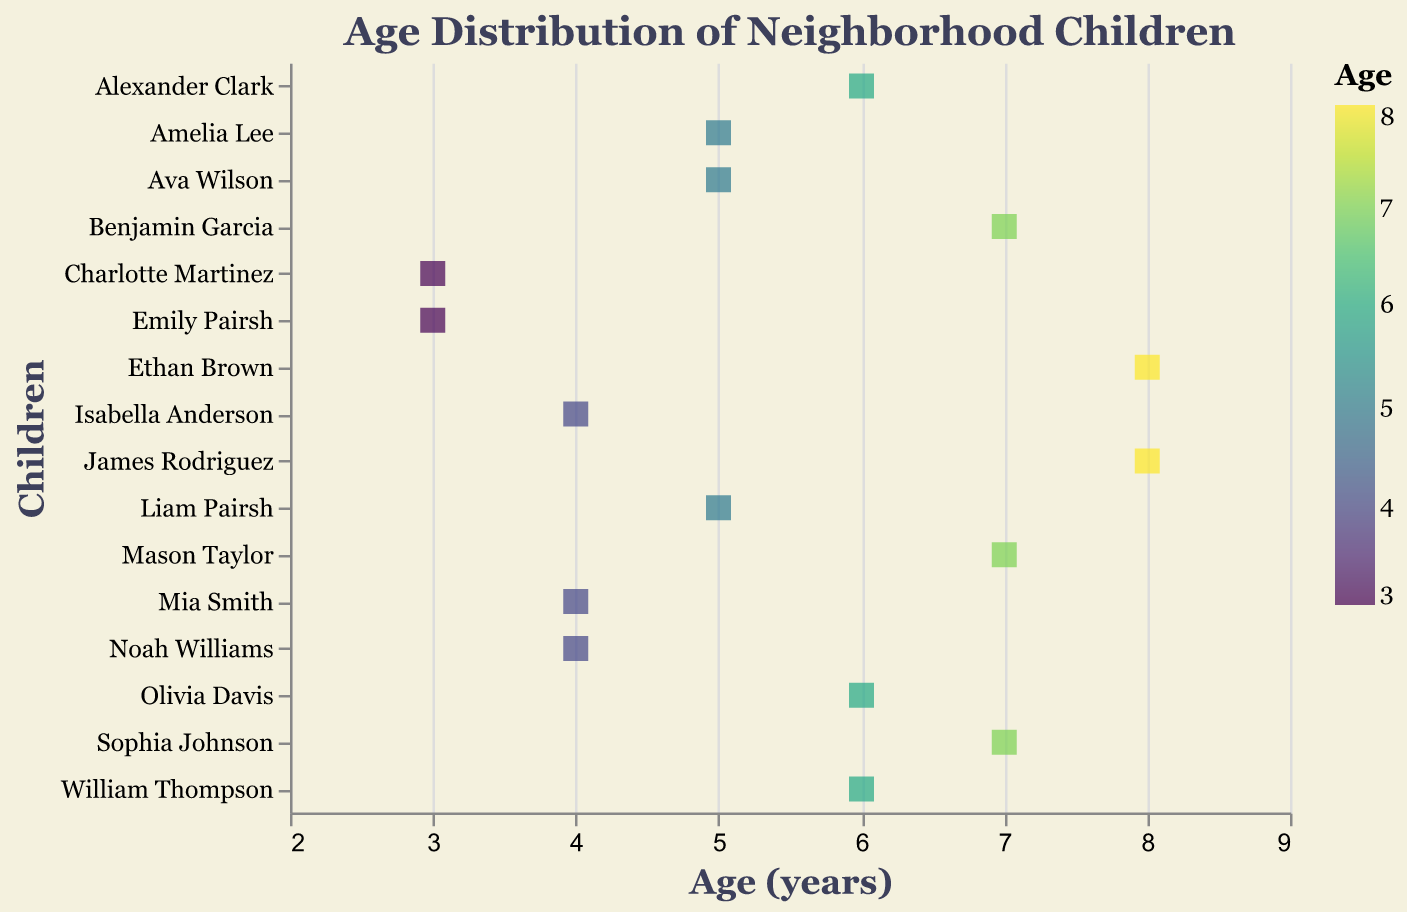What is the age range of the neighborhood children in the plot? The horizontal axis represents the children's ages. The lowest age value is 3 years, and the highest is 8 years.
Answer: 3 to 8 years How many children are aged 5 in the plot? By inspecting the plot, we observe that there are three data points (Liam Pairsh, Ava Wilson, and Amelia Lee) at the age of 5.
Answer: 3 children Which age has the highest frequency of children? We compare the number of children at each age: there are three children aged 5, three aged 7, and three aged 6. Therefore, ages 5, 6, and 7 all have the highest frequency.
Answer: 5, 6, and 7 Who is the youngest child, and what is their age? The plot shows two data points at the age of 3: Emily Pairsh and Charlotte Martinez. Both are the youngest, aged 3.
Answer: Emily Pairsh and Charlotte Martinez, age 3 Which child is aged 8 years old? By looking at the plot, we see Ethan Brown and James Rodriguez are represented at age 8.
Answer: Ethan Brown and James Rodriguez What is the median age of the children in the plot? Sorting the ages: 3, 3, 4, 4, 4, 5, 5, 5, 6, 6, 6, 7, 7, 7, 8, 8. With 16 children, the median is the average of the 8th and 9th values: (5+6)/2.
Answer: 5.5 years How many children are younger than 5 years old? Children aged 3 (2 children) and 4 (3 children). Total is 2 + 3 = 5.
Answer: 5 children Are there more children aged 6 or 7? By observing the plot, we see three children aged 6 and three children aged 7.
Answer: Equal number What's the average age of neighborhood children? Summing ages: 3+3+4+4+4+5+5+5+6+6+6+7+7+7+8+8 = 94. Number of children is 16. Average age = 94/16.
Answer: 5.875 years How many children are there in total in the plot? The plot contains 16 data points, each representing a child.
Answer: 16 children 